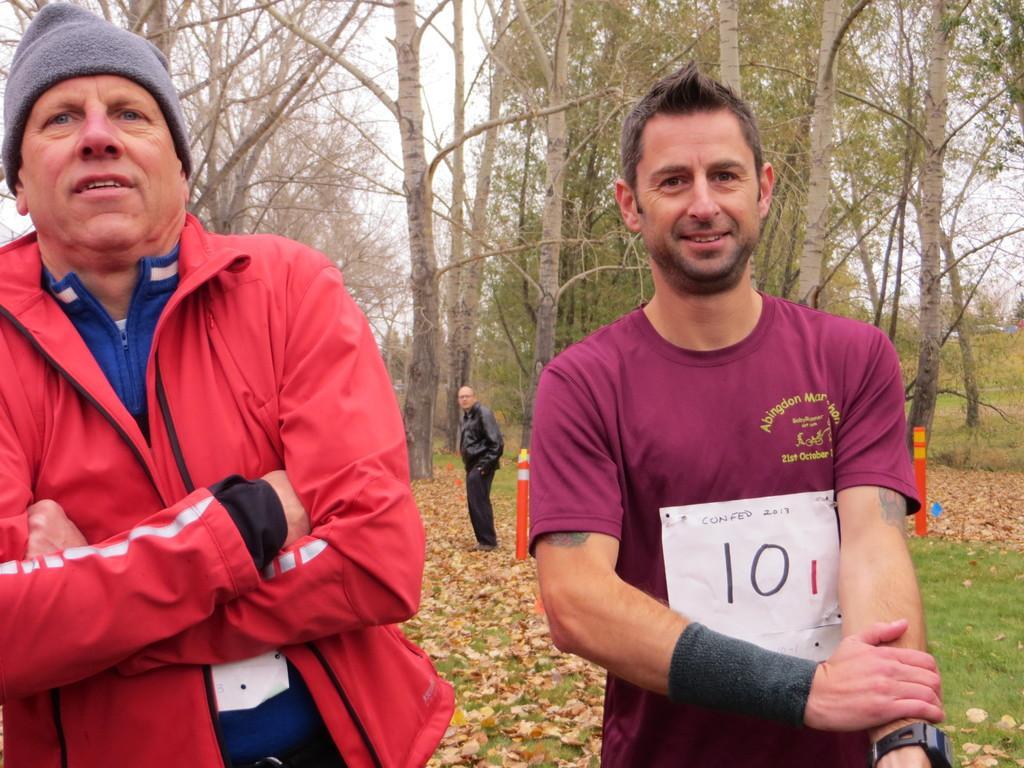Describe this image in one or two sentences. In this image I see 2 men who are standing and I see that this man is wearing a cap on his head and I see numbers on this paper. In the background I see number of trees and I see the grass and I see a man over here and I see the sky. 